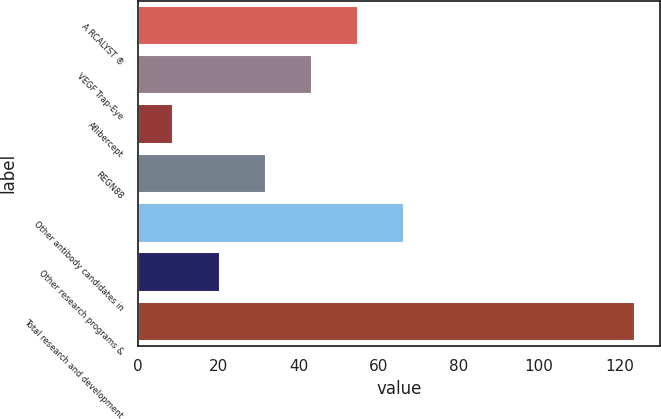<chart> <loc_0><loc_0><loc_500><loc_500><bar_chart><fcel>A RCALYST ®<fcel>VEGF Trap-Eye<fcel>Aflibercept<fcel>REGN88<fcel>Other antibody candidates in<fcel>Other research programs &<fcel>Total research and development<nl><fcel>54.84<fcel>43.33<fcel>8.8<fcel>31.82<fcel>66.35<fcel>20.31<fcel>123.9<nl></chart> 